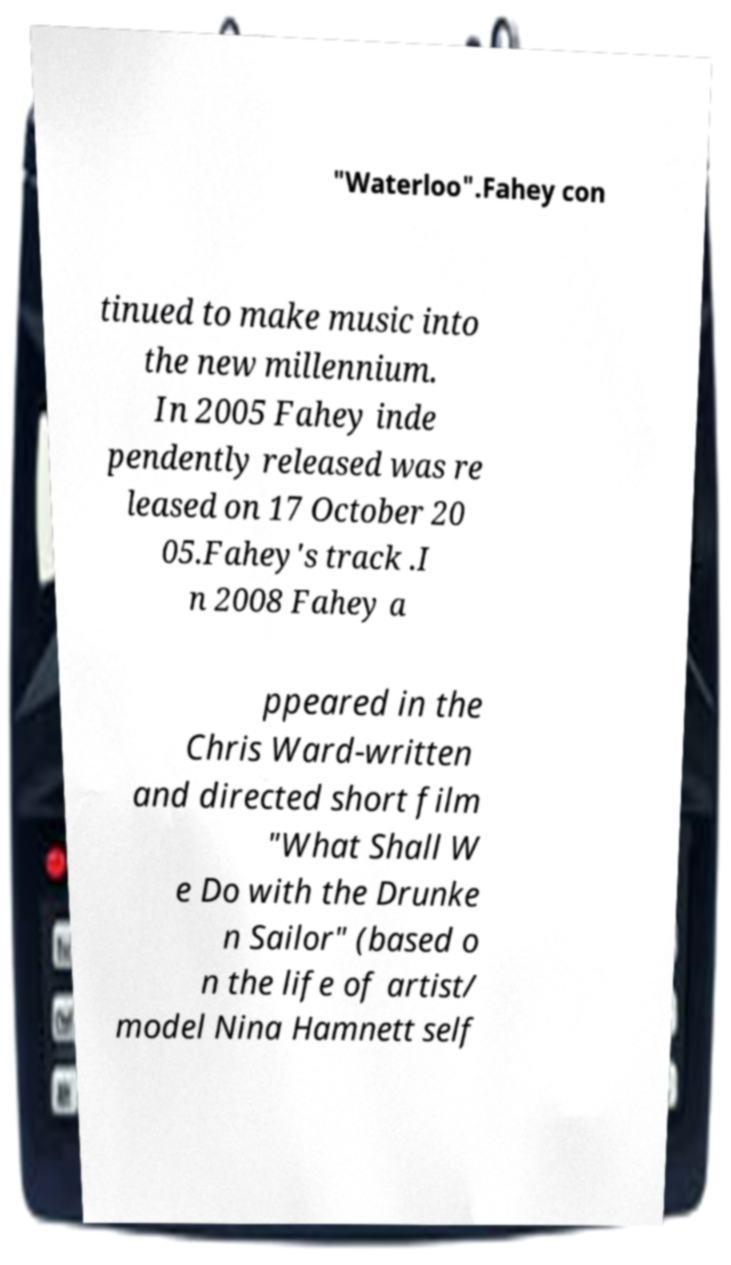Could you assist in decoding the text presented in this image and type it out clearly? "Waterloo".Fahey con tinued to make music into the new millennium. In 2005 Fahey inde pendently released was re leased on 17 October 20 05.Fahey's track .I n 2008 Fahey a ppeared in the Chris Ward-written and directed short film "What Shall W e Do with the Drunke n Sailor" (based o n the life of artist/ model Nina Hamnett self 